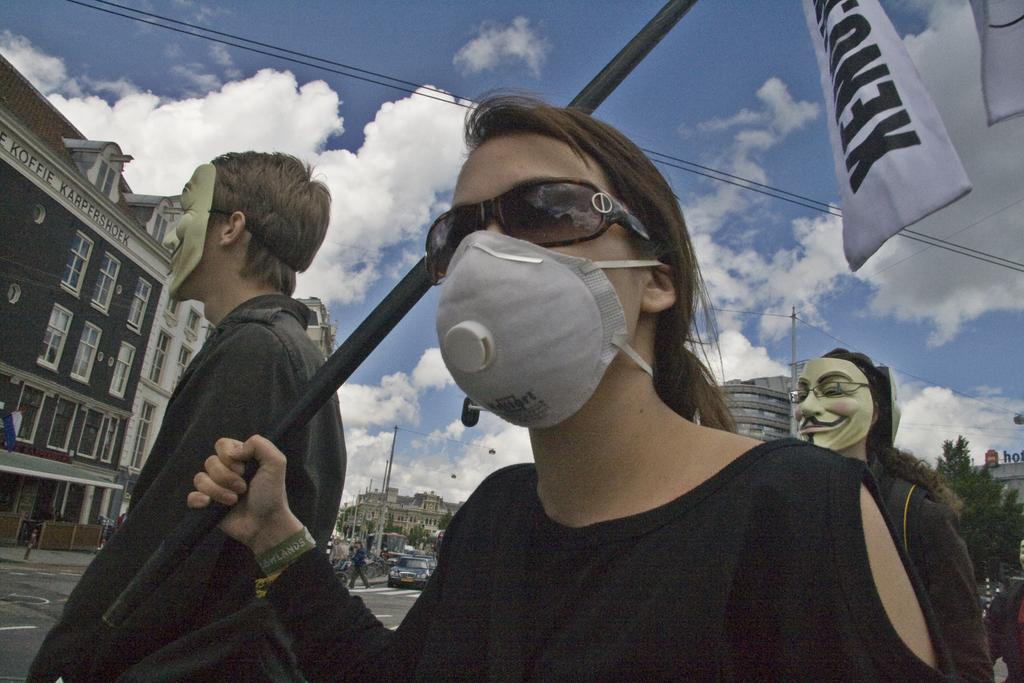What is the weather like in the image? The sky is cloudy in the image. What are the people in the image doing to protect themselves? The people in the image are wearing masks. What is the woman holding in the image? The woman is holding a rod. What can be seen in the background of the image? There are buildings with windows, a vehicle, and trees visible in the background. What type of sand can be seen in the image? There is no sand present in the image. What advertisement is being displayed on the buildings in the image? There is no advertisement visible on the buildings in the image. 